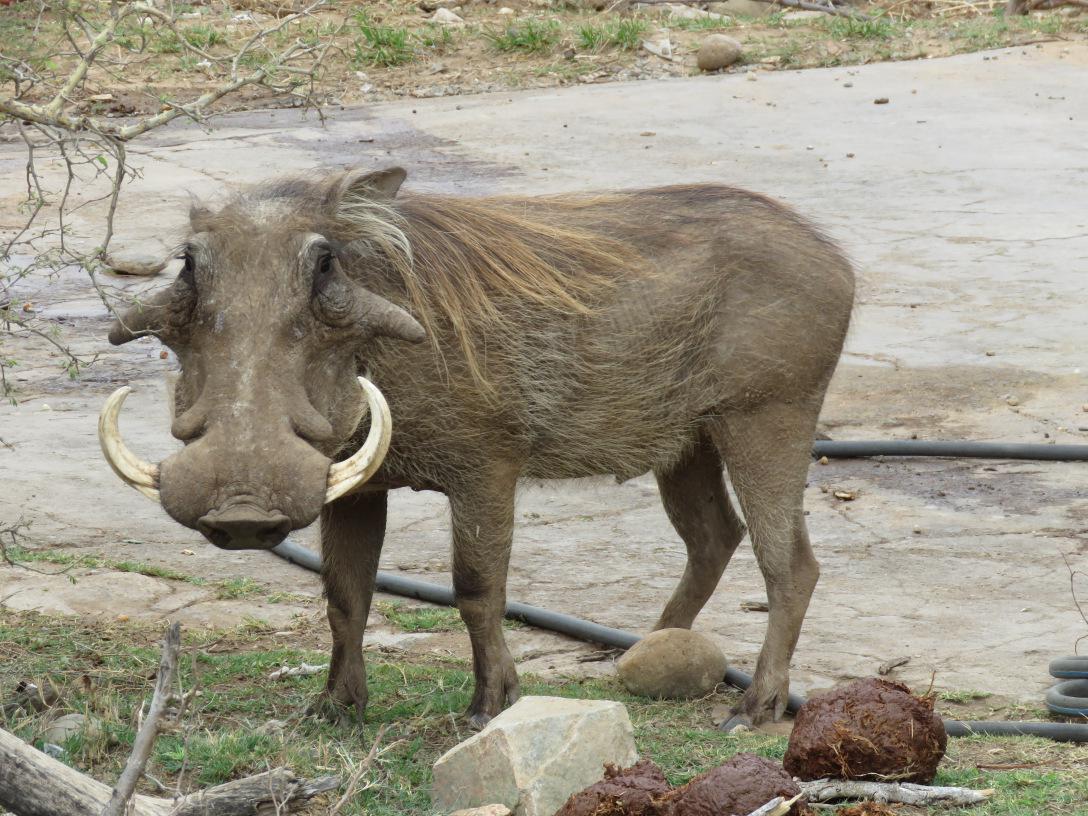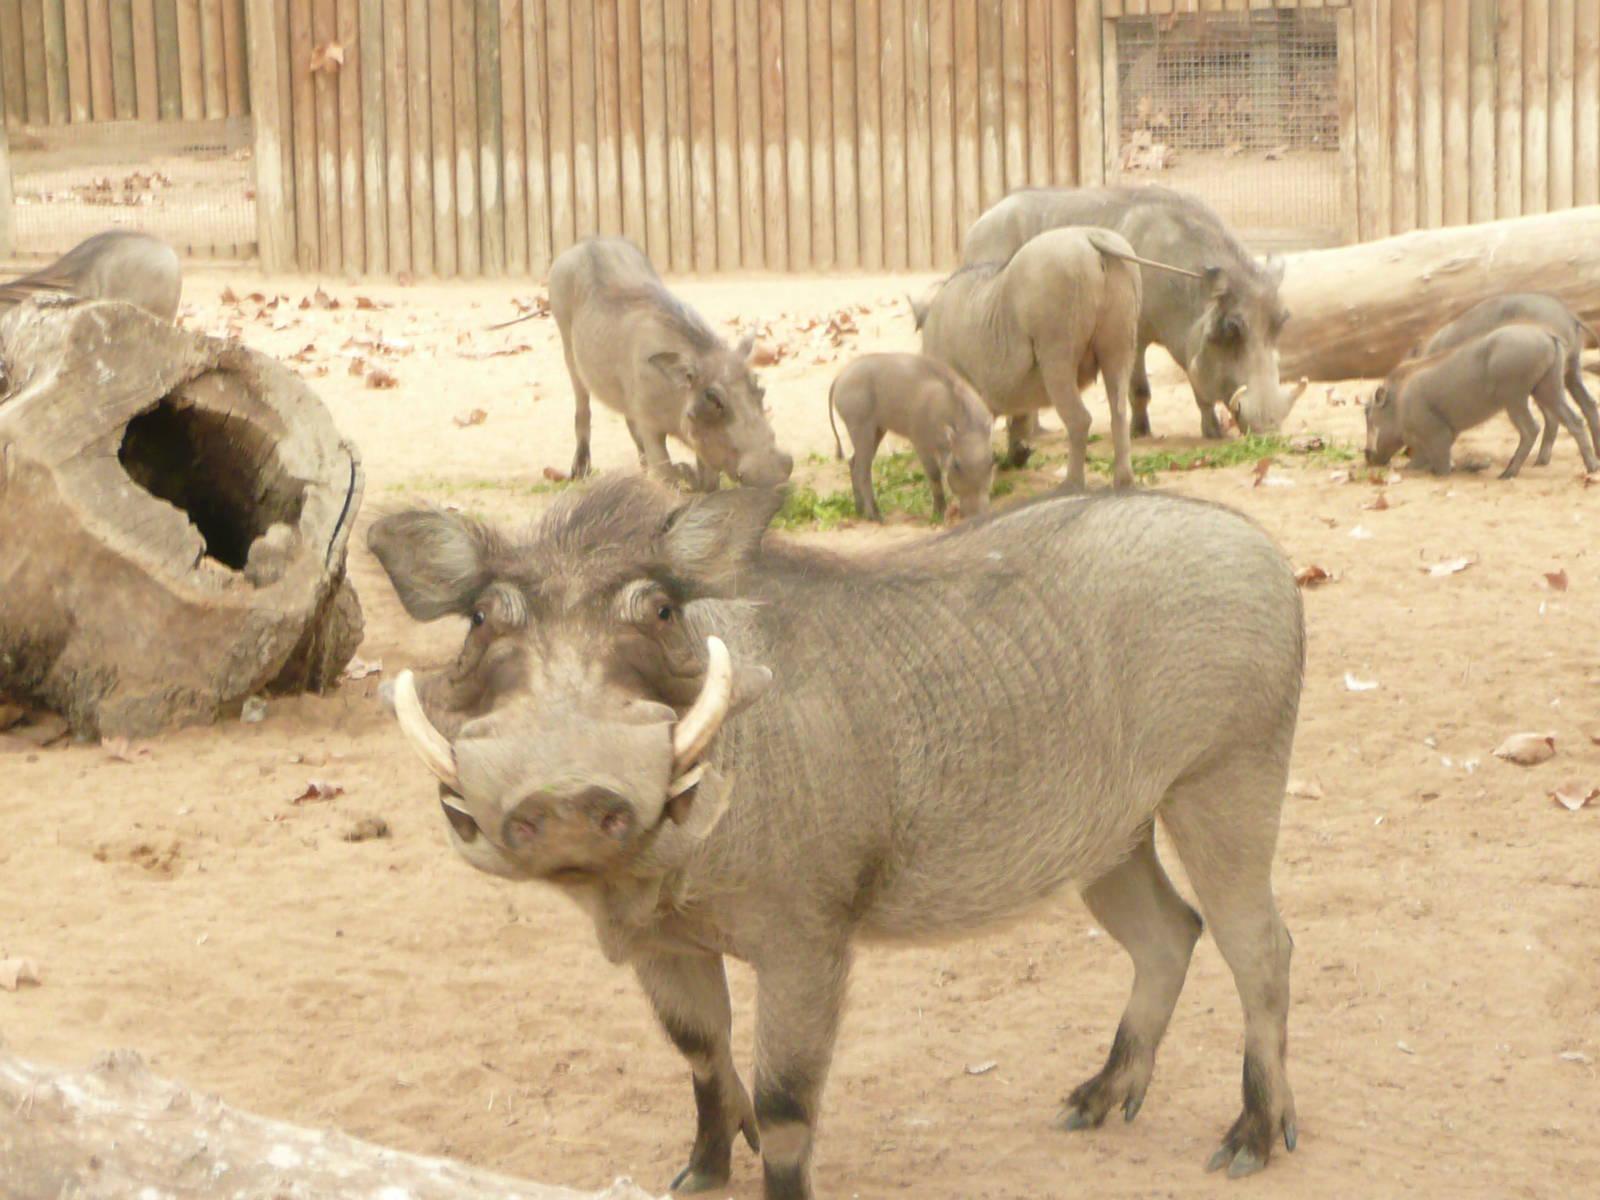The first image is the image on the left, the second image is the image on the right. Given the left and right images, does the statement "There is only one wart hog in the image on the left." hold true? Answer yes or no. Yes. The first image is the image on the left, the second image is the image on the right. For the images shown, is this caption "There are 9 or more warthogs, and there are only brown ones in one of the pictures, and only black ones in the other picture." true? Answer yes or no. No. 